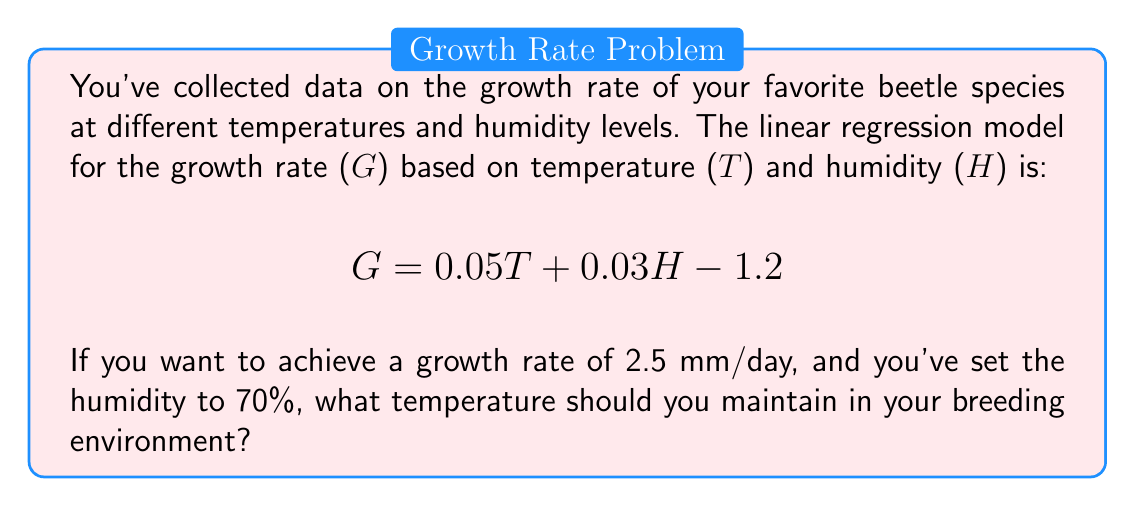Can you answer this question? Let's approach this step-by-step:

1) We start with the given linear regression equation:
   $$G = 0.05T + 0.03H - 1.2$$

2) We know the target growth rate (G) is 2.5 mm/day and the humidity (H) is set to 70%. Let's substitute these values:
   $$2.5 = 0.05T + 0.03(70) - 1.2$$

3) Simplify the right side of the equation:
   $$2.5 = 0.05T + 2.1 - 1.2$$
   $$2.5 = 0.05T + 0.9$$

4) Subtract 0.9 from both sides:
   $$1.6 = 0.05T$$

5) Divide both sides by 0.05 to isolate T:
   $$\frac{1.6}{0.05} = T$$
   $$32 = T$$

Therefore, to achieve a growth rate of 2.5 mm/day with a humidity of 70%, the temperature should be maintained at 32°C.
Answer: 32°C 